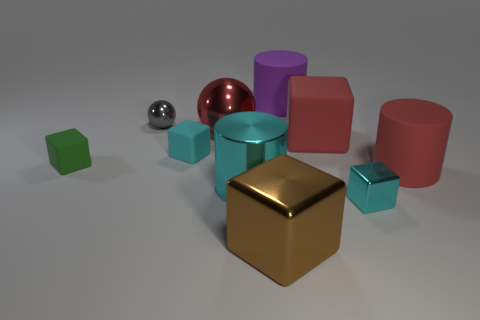Subtract all large matte cylinders. How many cylinders are left? 1 Subtract all green cubes. How many cubes are left? 4 Subtract all cylinders. How many objects are left? 7 Subtract all blue blocks. Subtract all cyan balls. How many blocks are left? 5 Subtract all cyan spheres. How many red cylinders are left? 1 Subtract all big purple matte cylinders. Subtract all large cylinders. How many objects are left? 6 Add 1 tiny gray metallic balls. How many tiny gray metallic balls are left? 2 Add 2 big purple cubes. How many big purple cubes exist? 2 Subtract 0 purple spheres. How many objects are left? 10 Subtract 1 cylinders. How many cylinders are left? 2 